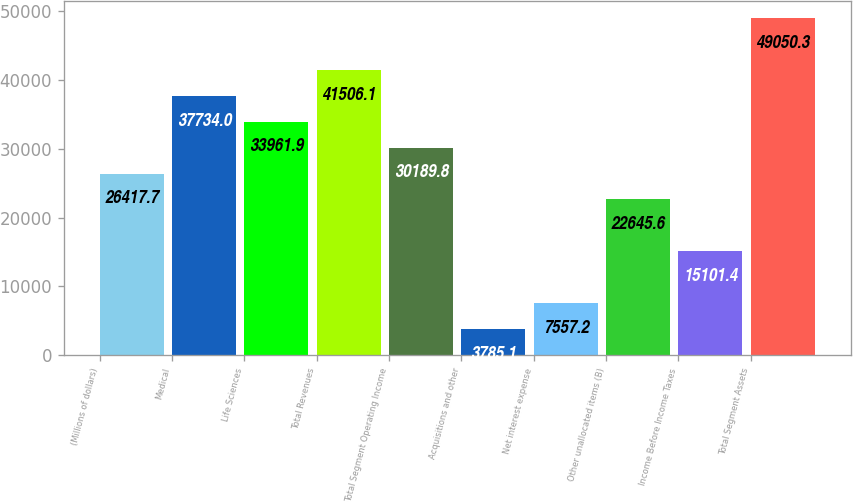Convert chart. <chart><loc_0><loc_0><loc_500><loc_500><bar_chart><fcel>(Millions of dollars)<fcel>Medical<fcel>Life Sciences<fcel>Total Revenues<fcel>Total Segment Operating Income<fcel>Acquisitions and other<fcel>Net interest expense<fcel>Other unallocated items (B)<fcel>Income Before Income Taxes<fcel>Total Segment Assets<nl><fcel>26417.7<fcel>37734<fcel>33961.9<fcel>41506.1<fcel>30189.8<fcel>3785.1<fcel>7557.2<fcel>22645.6<fcel>15101.4<fcel>49050.3<nl></chart> 